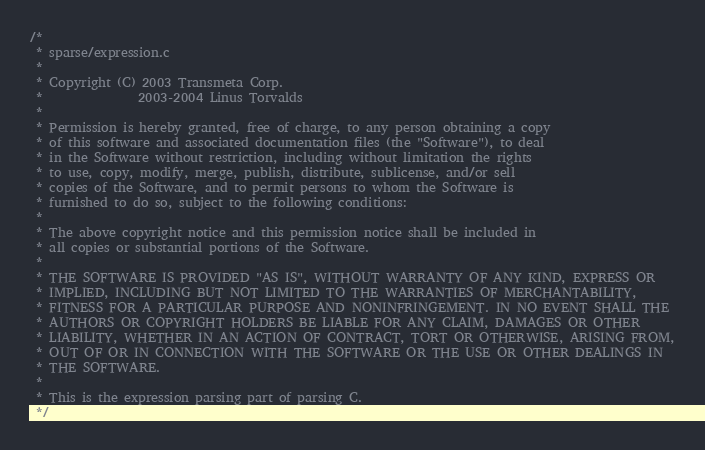Convert code to text. <code><loc_0><loc_0><loc_500><loc_500><_C_>/*
 * sparse/expression.c
 *
 * Copyright (C) 2003 Transmeta Corp.
 *               2003-2004 Linus Torvalds
 *
 * Permission is hereby granted, free of charge, to any person obtaining a copy
 * of this software and associated documentation files (the "Software"), to deal
 * in the Software without restriction, including without limitation the rights
 * to use, copy, modify, merge, publish, distribute, sublicense, and/or sell
 * copies of the Software, and to permit persons to whom the Software is
 * furnished to do so, subject to the following conditions:
 *
 * The above copyright notice and this permission notice shall be included in
 * all copies or substantial portions of the Software.
 *
 * THE SOFTWARE IS PROVIDED "AS IS", WITHOUT WARRANTY OF ANY KIND, EXPRESS OR
 * IMPLIED, INCLUDING BUT NOT LIMITED TO THE WARRANTIES OF MERCHANTABILITY,
 * FITNESS FOR A PARTICULAR PURPOSE AND NONINFRINGEMENT. IN NO EVENT SHALL THE
 * AUTHORS OR COPYRIGHT HOLDERS BE LIABLE FOR ANY CLAIM, DAMAGES OR OTHER
 * LIABILITY, WHETHER IN AN ACTION OF CONTRACT, TORT OR OTHERWISE, ARISING FROM,
 * OUT OF OR IN CONNECTION WITH THE SOFTWARE OR THE USE OR OTHER DEALINGS IN
 * THE SOFTWARE.
 *
 * This is the expression parsing part of parsing C.
 */</code> 